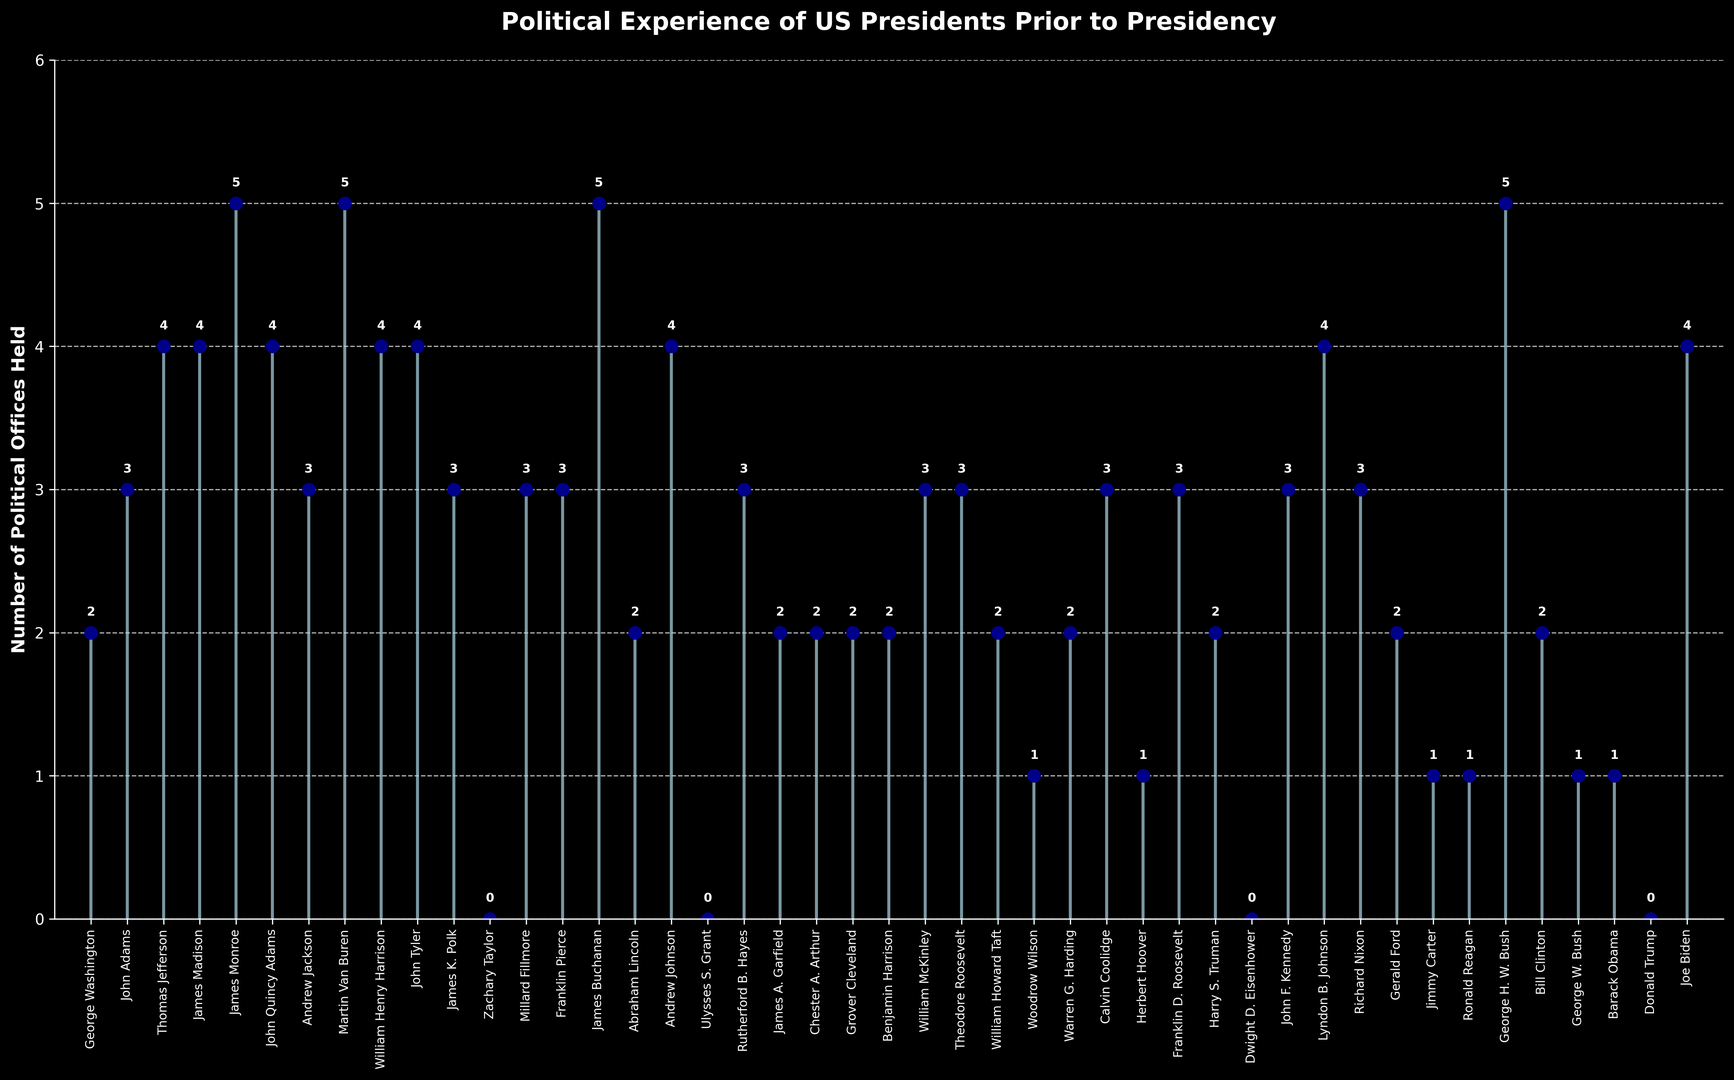What is the highest number of political offices held by any US president before their presidency? James Monroe, Martin Van Buren, James Buchanan, and George H. W. Bush each held 5 political offices before their presidency. The highest number of political offices held before the presidency is therefore 5.
Answer: 5 Which US president held the least number of political offices before their presidency? According to the plot, Zachary Taylor, Ulysses S. Grant, Dwight D. Eisenhower, and Donald Trump each held 0 political offices before their presidency, indicating they held the least number of offices.
Answer: Zachary Taylor, Ulysses S. Grant, Dwight D. Eisenhower, and Donald Trump What is the average number of political offices held by these US presidents before their presidency? Sum all the values (2+3+4+4+5+4+3+5+4+4+3+0+3+3+5+2+4+0+3+2+2+2+2+3+3+2+1+2+3+1+3+2+0+3+4+3+2+1+1+5+2+1+1+0+4) which equals 105, then divide by the number of presidents which is 45. 105/45 = 2.33. The average number of political offices held is approximately 2.33.
Answer: 2.33 How many presidents held exactly 3 political offices before their presidency? From the plot, the presidents that held exactly 3 political offices are John Adams, Andrew Jackson, James K. Polk, Millard Fillmore, Franklin Pierce, Rutherford B. Hayes, William McKinley, Theodore Roosevelt, Franklin D. Roosevelt, John F. Kennedy, Richard Nixon, and Calvin Coolidge. Counting these entries gives 12 presidents.
Answer: 12 Which US president held the most and the least political offices before their presidency in the 20th century? Based on the names and their tenure in the 20th century:
- Most: George H. W. Bush held 5 political offices.
- Least: Dwight D. Eisenhower (held 0 offices) and Donald Trump (held 0 offices).
Answer: George H. W. Bush (most), Dwight D. Eisenhower and Donald Trump (least) How many more political offices did James Monroe hold compared to Barack Obama before their presidency? James Monroe held 5 political offices, whereas Barack Obama held 1. The difference is 5 - 1 = 4.
Answer: 4 If you sum the political offices held by Abraham Lincoln and Ronald Reagan before their presidency, how does this compare to the number of offices held by James Buchanan alone? Abraham Lincoln held 2 offices and Ronald Reagan held 1, which sums up to 2 + 1 = 3. James Buchanan held 5 offices, which is 5 - 3 = 2 more than Lincoln and Reagan combined.
Answer: 2 more Which US presidents that became president in the 21st century held only 1 political office before their presidency? According to the plot and the dates, the US presidents in the 21st century who held only 1 political office before their presidency are George W. Bush and Barack Obama.
Answer: George W. Bush and Barack Obama 